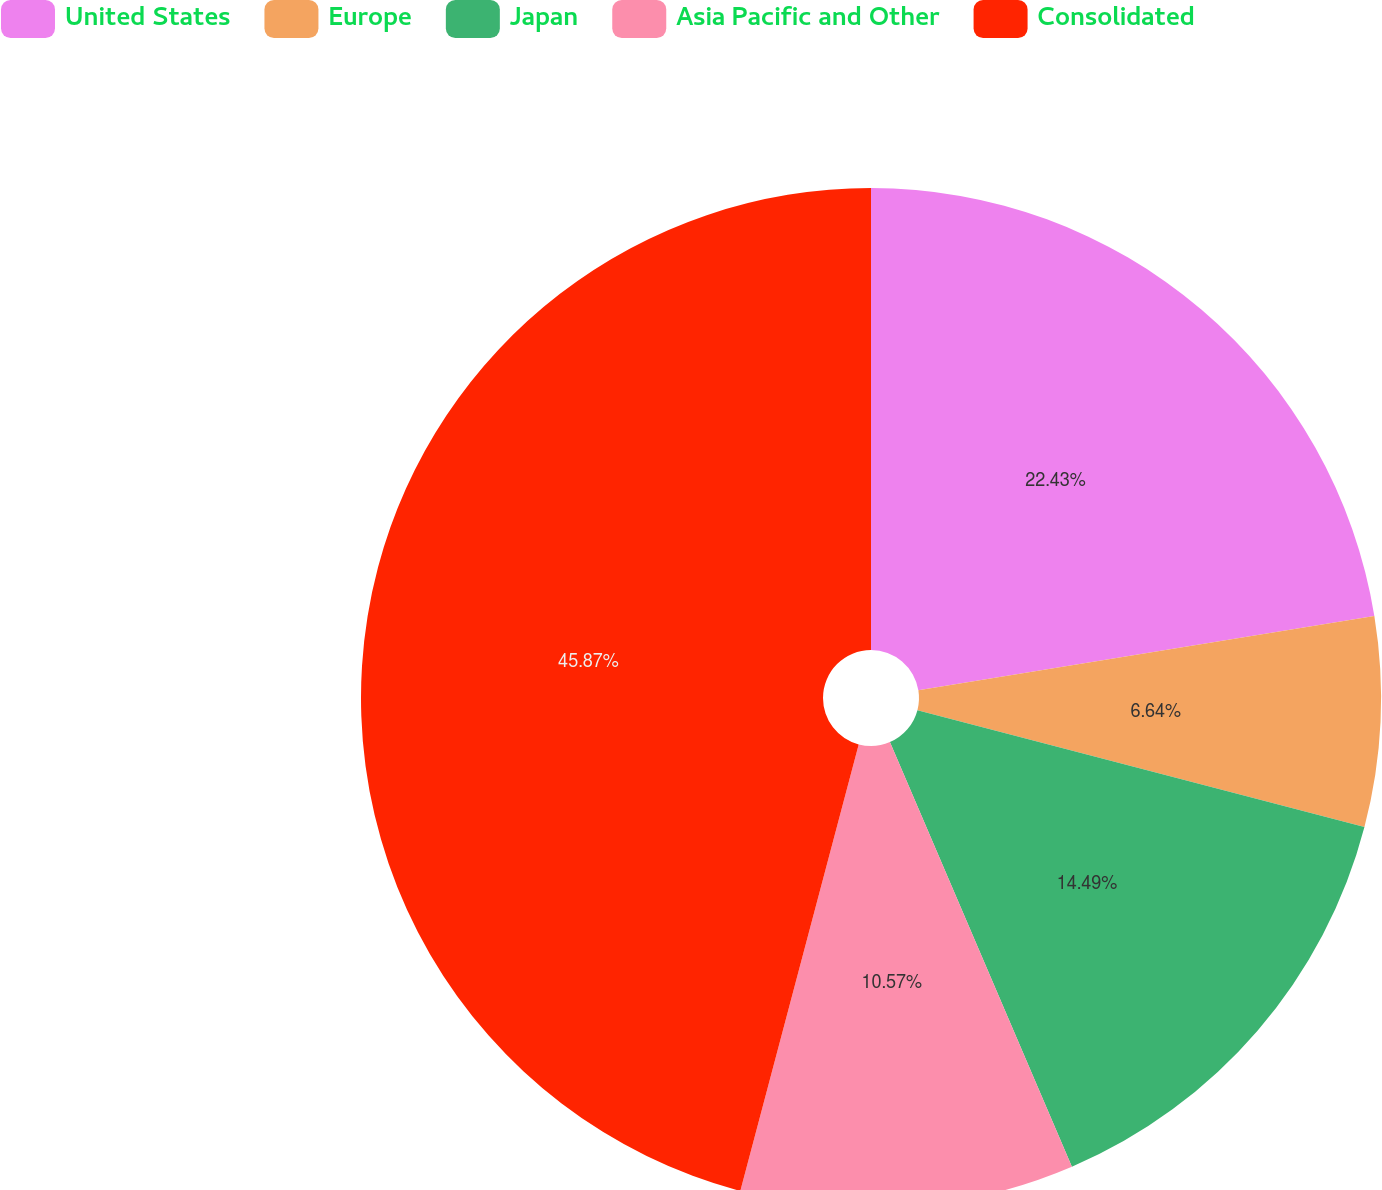<chart> <loc_0><loc_0><loc_500><loc_500><pie_chart><fcel>United States<fcel>Europe<fcel>Japan<fcel>Asia Pacific and Other<fcel>Consolidated<nl><fcel>22.43%<fcel>6.64%<fcel>14.49%<fcel>10.57%<fcel>45.88%<nl></chart> 